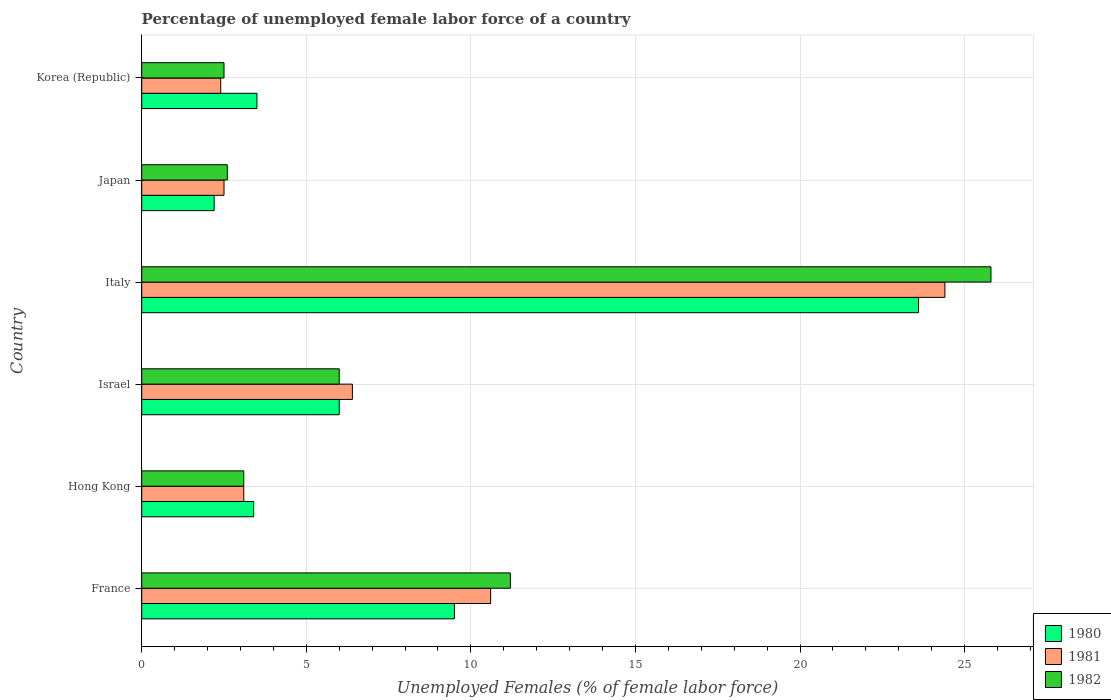How many different coloured bars are there?
Keep it short and to the point. 3. How many groups of bars are there?
Offer a terse response. 6. Are the number of bars per tick equal to the number of legend labels?
Offer a very short reply. Yes. Are the number of bars on each tick of the Y-axis equal?
Give a very brief answer. Yes. What is the label of the 3rd group of bars from the top?
Your answer should be very brief. Italy. What is the percentage of unemployed female labor force in 1981 in Korea (Republic)?
Provide a succinct answer. 2.4. Across all countries, what is the maximum percentage of unemployed female labor force in 1982?
Provide a short and direct response. 25.8. Across all countries, what is the minimum percentage of unemployed female labor force in 1982?
Provide a short and direct response. 2.5. In which country was the percentage of unemployed female labor force in 1982 minimum?
Offer a very short reply. Korea (Republic). What is the total percentage of unemployed female labor force in 1981 in the graph?
Ensure brevity in your answer.  49.4. What is the difference between the percentage of unemployed female labor force in 1982 in Hong Kong and that in Israel?
Offer a terse response. -2.9. What is the difference between the percentage of unemployed female labor force in 1980 in Israel and the percentage of unemployed female labor force in 1982 in Hong Kong?
Provide a succinct answer. 2.9. What is the average percentage of unemployed female labor force in 1980 per country?
Your response must be concise. 8.03. What is the difference between the percentage of unemployed female labor force in 1982 and percentage of unemployed female labor force in 1981 in France?
Make the answer very short. 0.6. In how many countries, is the percentage of unemployed female labor force in 1981 greater than 26 %?
Offer a very short reply. 0. What is the ratio of the percentage of unemployed female labor force in 1980 in France to that in Italy?
Offer a very short reply. 0.4. Is the difference between the percentage of unemployed female labor force in 1982 in Israel and Japan greater than the difference between the percentage of unemployed female labor force in 1981 in Israel and Japan?
Give a very brief answer. No. What is the difference between the highest and the second highest percentage of unemployed female labor force in 1981?
Keep it short and to the point. 13.8. What is the difference between the highest and the lowest percentage of unemployed female labor force in 1980?
Your answer should be compact. 21.4. What does the 1st bar from the bottom in Korea (Republic) represents?
Your answer should be compact. 1980. Is it the case that in every country, the sum of the percentage of unemployed female labor force in 1981 and percentage of unemployed female labor force in 1980 is greater than the percentage of unemployed female labor force in 1982?
Keep it short and to the point. Yes. Are all the bars in the graph horizontal?
Provide a succinct answer. Yes. What is the difference between two consecutive major ticks on the X-axis?
Provide a succinct answer. 5. Are the values on the major ticks of X-axis written in scientific E-notation?
Offer a terse response. No. How many legend labels are there?
Make the answer very short. 3. What is the title of the graph?
Keep it short and to the point. Percentage of unemployed female labor force of a country. Does "2009" appear as one of the legend labels in the graph?
Your answer should be compact. No. What is the label or title of the X-axis?
Your answer should be compact. Unemployed Females (% of female labor force). What is the label or title of the Y-axis?
Your answer should be very brief. Country. What is the Unemployed Females (% of female labor force) of 1981 in France?
Your answer should be compact. 10.6. What is the Unemployed Females (% of female labor force) in 1982 in France?
Provide a succinct answer. 11.2. What is the Unemployed Females (% of female labor force) in 1980 in Hong Kong?
Provide a short and direct response. 3.4. What is the Unemployed Females (% of female labor force) of 1981 in Hong Kong?
Your answer should be compact. 3.1. What is the Unemployed Females (% of female labor force) of 1982 in Hong Kong?
Make the answer very short. 3.1. What is the Unemployed Females (% of female labor force) in 1981 in Israel?
Ensure brevity in your answer.  6.4. What is the Unemployed Females (% of female labor force) of 1982 in Israel?
Your response must be concise. 6. What is the Unemployed Females (% of female labor force) in 1980 in Italy?
Provide a succinct answer. 23.6. What is the Unemployed Females (% of female labor force) of 1981 in Italy?
Offer a terse response. 24.4. What is the Unemployed Females (% of female labor force) of 1982 in Italy?
Offer a very short reply. 25.8. What is the Unemployed Females (% of female labor force) in 1980 in Japan?
Your response must be concise. 2.2. What is the Unemployed Females (% of female labor force) in 1981 in Japan?
Offer a terse response. 2.5. What is the Unemployed Females (% of female labor force) of 1982 in Japan?
Ensure brevity in your answer.  2.6. What is the Unemployed Females (% of female labor force) of 1980 in Korea (Republic)?
Provide a succinct answer. 3.5. What is the Unemployed Females (% of female labor force) of 1981 in Korea (Republic)?
Your answer should be compact. 2.4. What is the Unemployed Females (% of female labor force) in 1982 in Korea (Republic)?
Your response must be concise. 2.5. Across all countries, what is the maximum Unemployed Females (% of female labor force) in 1980?
Keep it short and to the point. 23.6. Across all countries, what is the maximum Unemployed Females (% of female labor force) in 1981?
Your answer should be very brief. 24.4. Across all countries, what is the maximum Unemployed Females (% of female labor force) of 1982?
Offer a very short reply. 25.8. Across all countries, what is the minimum Unemployed Females (% of female labor force) of 1980?
Your answer should be very brief. 2.2. Across all countries, what is the minimum Unemployed Females (% of female labor force) in 1981?
Provide a succinct answer. 2.4. What is the total Unemployed Females (% of female labor force) in 1980 in the graph?
Make the answer very short. 48.2. What is the total Unemployed Females (% of female labor force) in 1981 in the graph?
Ensure brevity in your answer.  49.4. What is the total Unemployed Females (% of female labor force) in 1982 in the graph?
Your answer should be compact. 51.2. What is the difference between the Unemployed Females (% of female labor force) of 1980 in France and that in Hong Kong?
Ensure brevity in your answer.  6.1. What is the difference between the Unemployed Females (% of female labor force) in 1981 in France and that in Hong Kong?
Offer a terse response. 7.5. What is the difference between the Unemployed Females (% of female labor force) of 1982 in France and that in Hong Kong?
Ensure brevity in your answer.  8.1. What is the difference between the Unemployed Females (% of female labor force) in 1980 in France and that in Israel?
Offer a terse response. 3.5. What is the difference between the Unemployed Females (% of female labor force) of 1982 in France and that in Israel?
Provide a short and direct response. 5.2. What is the difference between the Unemployed Females (% of female labor force) in 1980 in France and that in Italy?
Offer a terse response. -14.1. What is the difference between the Unemployed Females (% of female labor force) of 1981 in France and that in Italy?
Your answer should be very brief. -13.8. What is the difference between the Unemployed Females (% of female labor force) of 1982 in France and that in Italy?
Provide a short and direct response. -14.6. What is the difference between the Unemployed Females (% of female labor force) in 1980 in France and that in Japan?
Offer a terse response. 7.3. What is the difference between the Unemployed Females (% of female labor force) in 1981 in France and that in Japan?
Give a very brief answer. 8.1. What is the difference between the Unemployed Females (% of female labor force) in 1980 in France and that in Korea (Republic)?
Keep it short and to the point. 6. What is the difference between the Unemployed Females (% of female labor force) in 1980 in Hong Kong and that in Italy?
Your response must be concise. -20.2. What is the difference between the Unemployed Females (% of female labor force) in 1981 in Hong Kong and that in Italy?
Provide a short and direct response. -21.3. What is the difference between the Unemployed Females (% of female labor force) of 1982 in Hong Kong and that in Italy?
Provide a short and direct response. -22.7. What is the difference between the Unemployed Females (% of female labor force) of 1980 in Hong Kong and that in Korea (Republic)?
Provide a succinct answer. -0.1. What is the difference between the Unemployed Females (% of female labor force) of 1982 in Hong Kong and that in Korea (Republic)?
Offer a very short reply. 0.6. What is the difference between the Unemployed Females (% of female labor force) of 1980 in Israel and that in Italy?
Your answer should be compact. -17.6. What is the difference between the Unemployed Females (% of female labor force) in 1981 in Israel and that in Italy?
Your answer should be compact. -18. What is the difference between the Unemployed Females (% of female labor force) of 1982 in Israel and that in Italy?
Keep it short and to the point. -19.8. What is the difference between the Unemployed Females (% of female labor force) in 1980 in Israel and that in Japan?
Provide a short and direct response. 3.8. What is the difference between the Unemployed Females (% of female labor force) of 1981 in Israel and that in Japan?
Your answer should be compact. 3.9. What is the difference between the Unemployed Females (% of female labor force) of 1982 in Israel and that in Japan?
Your answer should be compact. 3.4. What is the difference between the Unemployed Females (% of female labor force) of 1982 in Israel and that in Korea (Republic)?
Offer a very short reply. 3.5. What is the difference between the Unemployed Females (% of female labor force) of 1980 in Italy and that in Japan?
Your response must be concise. 21.4. What is the difference between the Unemployed Females (% of female labor force) in 1981 in Italy and that in Japan?
Provide a succinct answer. 21.9. What is the difference between the Unemployed Females (% of female labor force) in 1982 in Italy and that in Japan?
Provide a succinct answer. 23.2. What is the difference between the Unemployed Females (% of female labor force) of 1980 in Italy and that in Korea (Republic)?
Provide a succinct answer. 20.1. What is the difference between the Unemployed Females (% of female labor force) of 1982 in Italy and that in Korea (Republic)?
Ensure brevity in your answer.  23.3. What is the difference between the Unemployed Females (% of female labor force) of 1980 in Japan and that in Korea (Republic)?
Offer a very short reply. -1.3. What is the difference between the Unemployed Females (% of female labor force) of 1981 in Japan and that in Korea (Republic)?
Give a very brief answer. 0.1. What is the difference between the Unemployed Females (% of female labor force) in 1982 in Japan and that in Korea (Republic)?
Give a very brief answer. 0.1. What is the difference between the Unemployed Females (% of female labor force) in 1980 in France and the Unemployed Females (% of female labor force) in 1981 in Hong Kong?
Your answer should be compact. 6.4. What is the difference between the Unemployed Females (% of female labor force) of 1980 in France and the Unemployed Females (% of female labor force) of 1982 in Israel?
Give a very brief answer. 3.5. What is the difference between the Unemployed Females (% of female labor force) of 1980 in France and the Unemployed Females (% of female labor force) of 1981 in Italy?
Provide a succinct answer. -14.9. What is the difference between the Unemployed Females (% of female labor force) in 1980 in France and the Unemployed Females (% of female labor force) in 1982 in Italy?
Provide a succinct answer. -16.3. What is the difference between the Unemployed Females (% of female labor force) in 1981 in France and the Unemployed Females (% of female labor force) in 1982 in Italy?
Give a very brief answer. -15.2. What is the difference between the Unemployed Females (% of female labor force) in 1981 in France and the Unemployed Females (% of female labor force) in 1982 in Japan?
Offer a terse response. 8. What is the difference between the Unemployed Females (% of female labor force) in 1980 in France and the Unemployed Females (% of female labor force) in 1982 in Korea (Republic)?
Your response must be concise. 7. What is the difference between the Unemployed Females (% of female labor force) of 1981 in France and the Unemployed Females (% of female labor force) of 1982 in Korea (Republic)?
Make the answer very short. 8.1. What is the difference between the Unemployed Females (% of female labor force) of 1980 in Hong Kong and the Unemployed Females (% of female labor force) of 1982 in Israel?
Make the answer very short. -2.6. What is the difference between the Unemployed Females (% of female labor force) in 1981 in Hong Kong and the Unemployed Females (% of female labor force) in 1982 in Israel?
Provide a short and direct response. -2.9. What is the difference between the Unemployed Females (% of female labor force) in 1980 in Hong Kong and the Unemployed Females (% of female labor force) in 1981 in Italy?
Make the answer very short. -21. What is the difference between the Unemployed Females (% of female labor force) in 1980 in Hong Kong and the Unemployed Females (% of female labor force) in 1982 in Italy?
Make the answer very short. -22.4. What is the difference between the Unemployed Females (% of female labor force) of 1981 in Hong Kong and the Unemployed Females (% of female labor force) of 1982 in Italy?
Your answer should be very brief. -22.7. What is the difference between the Unemployed Females (% of female labor force) in 1980 in Hong Kong and the Unemployed Females (% of female labor force) in 1981 in Japan?
Make the answer very short. 0.9. What is the difference between the Unemployed Females (% of female labor force) of 1980 in Hong Kong and the Unemployed Females (% of female labor force) of 1982 in Japan?
Give a very brief answer. 0.8. What is the difference between the Unemployed Females (% of female labor force) of 1980 in Hong Kong and the Unemployed Females (% of female labor force) of 1981 in Korea (Republic)?
Your response must be concise. 1. What is the difference between the Unemployed Females (% of female labor force) of 1980 in Hong Kong and the Unemployed Females (% of female labor force) of 1982 in Korea (Republic)?
Offer a terse response. 0.9. What is the difference between the Unemployed Females (% of female labor force) in 1981 in Hong Kong and the Unemployed Females (% of female labor force) in 1982 in Korea (Republic)?
Offer a terse response. 0.6. What is the difference between the Unemployed Females (% of female labor force) of 1980 in Israel and the Unemployed Females (% of female labor force) of 1981 in Italy?
Offer a terse response. -18.4. What is the difference between the Unemployed Females (% of female labor force) in 1980 in Israel and the Unemployed Females (% of female labor force) in 1982 in Italy?
Ensure brevity in your answer.  -19.8. What is the difference between the Unemployed Females (% of female labor force) in 1981 in Israel and the Unemployed Females (% of female labor force) in 1982 in Italy?
Provide a short and direct response. -19.4. What is the difference between the Unemployed Females (% of female labor force) of 1980 in Israel and the Unemployed Females (% of female labor force) of 1981 in Korea (Republic)?
Your answer should be very brief. 3.6. What is the difference between the Unemployed Females (% of female labor force) in 1980 in Israel and the Unemployed Females (% of female labor force) in 1982 in Korea (Republic)?
Provide a succinct answer. 3.5. What is the difference between the Unemployed Females (% of female labor force) in 1981 in Israel and the Unemployed Females (% of female labor force) in 1982 in Korea (Republic)?
Offer a very short reply. 3.9. What is the difference between the Unemployed Females (% of female labor force) in 1980 in Italy and the Unemployed Females (% of female labor force) in 1981 in Japan?
Your response must be concise. 21.1. What is the difference between the Unemployed Females (% of female labor force) in 1980 in Italy and the Unemployed Females (% of female labor force) in 1982 in Japan?
Your response must be concise. 21. What is the difference between the Unemployed Females (% of female labor force) of 1981 in Italy and the Unemployed Females (% of female labor force) of 1982 in Japan?
Provide a succinct answer. 21.8. What is the difference between the Unemployed Females (% of female labor force) in 1980 in Italy and the Unemployed Females (% of female labor force) in 1981 in Korea (Republic)?
Your response must be concise. 21.2. What is the difference between the Unemployed Females (% of female labor force) in 1980 in Italy and the Unemployed Females (% of female labor force) in 1982 in Korea (Republic)?
Your answer should be very brief. 21.1. What is the difference between the Unemployed Females (% of female labor force) in 1981 in Italy and the Unemployed Females (% of female labor force) in 1982 in Korea (Republic)?
Your answer should be compact. 21.9. What is the average Unemployed Females (% of female labor force) in 1980 per country?
Your response must be concise. 8.03. What is the average Unemployed Females (% of female labor force) in 1981 per country?
Give a very brief answer. 8.23. What is the average Unemployed Females (% of female labor force) in 1982 per country?
Give a very brief answer. 8.53. What is the difference between the Unemployed Females (% of female labor force) in 1980 and Unemployed Females (% of female labor force) in 1981 in France?
Give a very brief answer. -1.1. What is the difference between the Unemployed Females (% of female labor force) in 1981 and Unemployed Females (% of female labor force) in 1982 in France?
Give a very brief answer. -0.6. What is the difference between the Unemployed Females (% of female labor force) in 1980 and Unemployed Females (% of female labor force) in 1982 in Hong Kong?
Your answer should be very brief. 0.3. What is the difference between the Unemployed Females (% of female labor force) in 1981 and Unemployed Females (% of female labor force) in 1982 in Hong Kong?
Your answer should be compact. 0. What is the difference between the Unemployed Females (% of female labor force) in 1980 and Unemployed Females (% of female labor force) in 1982 in Israel?
Your answer should be compact. 0. What is the difference between the Unemployed Females (% of female labor force) in 1981 and Unemployed Females (% of female labor force) in 1982 in Israel?
Offer a very short reply. 0.4. What is the difference between the Unemployed Females (% of female labor force) in 1980 and Unemployed Females (% of female labor force) in 1981 in Italy?
Provide a succinct answer. -0.8. What is the difference between the Unemployed Females (% of female labor force) of 1980 and Unemployed Females (% of female labor force) of 1981 in Korea (Republic)?
Provide a short and direct response. 1.1. What is the difference between the Unemployed Females (% of female labor force) in 1980 and Unemployed Females (% of female labor force) in 1982 in Korea (Republic)?
Provide a succinct answer. 1. What is the ratio of the Unemployed Females (% of female labor force) in 1980 in France to that in Hong Kong?
Keep it short and to the point. 2.79. What is the ratio of the Unemployed Females (% of female labor force) in 1981 in France to that in Hong Kong?
Your answer should be very brief. 3.42. What is the ratio of the Unemployed Females (% of female labor force) of 1982 in France to that in Hong Kong?
Provide a short and direct response. 3.61. What is the ratio of the Unemployed Females (% of female labor force) in 1980 in France to that in Israel?
Ensure brevity in your answer.  1.58. What is the ratio of the Unemployed Females (% of female labor force) of 1981 in France to that in Israel?
Keep it short and to the point. 1.66. What is the ratio of the Unemployed Females (% of female labor force) in 1982 in France to that in Israel?
Your answer should be very brief. 1.87. What is the ratio of the Unemployed Females (% of female labor force) of 1980 in France to that in Italy?
Offer a terse response. 0.4. What is the ratio of the Unemployed Females (% of female labor force) in 1981 in France to that in Italy?
Keep it short and to the point. 0.43. What is the ratio of the Unemployed Females (% of female labor force) of 1982 in France to that in Italy?
Make the answer very short. 0.43. What is the ratio of the Unemployed Females (% of female labor force) in 1980 in France to that in Japan?
Provide a short and direct response. 4.32. What is the ratio of the Unemployed Females (% of female labor force) of 1981 in France to that in Japan?
Offer a terse response. 4.24. What is the ratio of the Unemployed Females (% of female labor force) of 1982 in France to that in Japan?
Offer a terse response. 4.31. What is the ratio of the Unemployed Females (% of female labor force) of 1980 in France to that in Korea (Republic)?
Ensure brevity in your answer.  2.71. What is the ratio of the Unemployed Females (% of female labor force) in 1981 in France to that in Korea (Republic)?
Make the answer very short. 4.42. What is the ratio of the Unemployed Females (% of female labor force) of 1982 in France to that in Korea (Republic)?
Your answer should be very brief. 4.48. What is the ratio of the Unemployed Females (% of female labor force) of 1980 in Hong Kong to that in Israel?
Make the answer very short. 0.57. What is the ratio of the Unemployed Females (% of female labor force) in 1981 in Hong Kong to that in Israel?
Offer a terse response. 0.48. What is the ratio of the Unemployed Females (% of female labor force) in 1982 in Hong Kong to that in Israel?
Keep it short and to the point. 0.52. What is the ratio of the Unemployed Females (% of female labor force) in 1980 in Hong Kong to that in Italy?
Provide a succinct answer. 0.14. What is the ratio of the Unemployed Females (% of female labor force) in 1981 in Hong Kong to that in Italy?
Make the answer very short. 0.13. What is the ratio of the Unemployed Females (% of female labor force) of 1982 in Hong Kong to that in Italy?
Your answer should be compact. 0.12. What is the ratio of the Unemployed Females (% of female labor force) of 1980 in Hong Kong to that in Japan?
Offer a very short reply. 1.55. What is the ratio of the Unemployed Females (% of female labor force) in 1981 in Hong Kong to that in Japan?
Ensure brevity in your answer.  1.24. What is the ratio of the Unemployed Females (% of female labor force) in 1982 in Hong Kong to that in Japan?
Make the answer very short. 1.19. What is the ratio of the Unemployed Females (% of female labor force) of 1980 in Hong Kong to that in Korea (Republic)?
Offer a terse response. 0.97. What is the ratio of the Unemployed Females (% of female labor force) of 1981 in Hong Kong to that in Korea (Republic)?
Ensure brevity in your answer.  1.29. What is the ratio of the Unemployed Females (% of female labor force) in 1982 in Hong Kong to that in Korea (Republic)?
Offer a very short reply. 1.24. What is the ratio of the Unemployed Females (% of female labor force) of 1980 in Israel to that in Italy?
Make the answer very short. 0.25. What is the ratio of the Unemployed Females (% of female labor force) in 1981 in Israel to that in Italy?
Provide a short and direct response. 0.26. What is the ratio of the Unemployed Females (% of female labor force) in 1982 in Israel to that in Italy?
Keep it short and to the point. 0.23. What is the ratio of the Unemployed Females (% of female labor force) in 1980 in Israel to that in Japan?
Your answer should be compact. 2.73. What is the ratio of the Unemployed Females (% of female labor force) of 1981 in Israel to that in Japan?
Make the answer very short. 2.56. What is the ratio of the Unemployed Females (% of female labor force) of 1982 in Israel to that in Japan?
Provide a succinct answer. 2.31. What is the ratio of the Unemployed Females (% of female labor force) of 1980 in Israel to that in Korea (Republic)?
Offer a very short reply. 1.71. What is the ratio of the Unemployed Females (% of female labor force) in 1981 in Israel to that in Korea (Republic)?
Your answer should be very brief. 2.67. What is the ratio of the Unemployed Females (% of female labor force) of 1982 in Israel to that in Korea (Republic)?
Make the answer very short. 2.4. What is the ratio of the Unemployed Females (% of female labor force) of 1980 in Italy to that in Japan?
Ensure brevity in your answer.  10.73. What is the ratio of the Unemployed Females (% of female labor force) in 1981 in Italy to that in Japan?
Offer a terse response. 9.76. What is the ratio of the Unemployed Females (% of female labor force) of 1982 in Italy to that in Japan?
Provide a short and direct response. 9.92. What is the ratio of the Unemployed Females (% of female labor force) in 1980 in Italy to that in Korea (Republic)?
Offer a very short reply. 6.74. What is the ratio of the Unemployed Females (% of female labor force) in 1981 in Italy to that in Korea (Republic)?
Make the answer very short. 10.17. What is the ratio of the Unemployed Females (% of female labor force) in 1982 in Italy to that in Korea (Republic)?
Provide a short and direct response. 10.32. What is the ratio of the Unemployed Females (% of female labor force) in 1980 in Japan to that in Korea (Republic)?
Your answer should be very brief. 0.63. What is the ratio of the Unemployed Females (% of female labor force) in 1981 in Japan to that in Korea (Republic)?
Make the answer very short. 1.04. What is the difference between the highest and the second highest Unemployed Females (% of female labor force) of 1982?
Make the answer very short. 14.6. What is the difference between the highest and the lowest Unemployed Females (% of female labor force) in 1980?
Offer a very short reply. 21.4. What is the difference between the highest and the lowest Unemployed Females (% of female labor force) in 1981?
Keep it short and to the point. 22. What is the difference between the highest and the lowest Unemployed Females (% of female labor force) in 1982?
Ensure brevity in your answer.  23.3. 